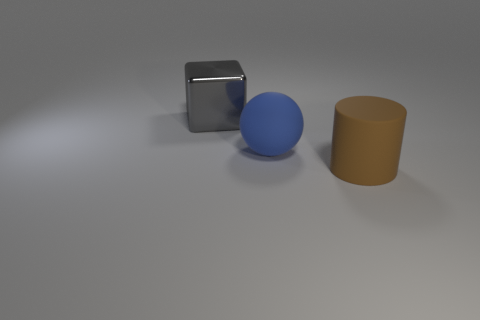What number of big blocks are behind the large object behind the ball?
Offer a terse response. 0. Is there anything else that is the same material as the gray cube?
Offer a terse response. No. Does the large brown object have the same material as the large thing behind the large matte ball?
Your answer should be very brief. No. Are there fewer big rubber cylinders that are on the left side of the big blue rubber thing than metal objects in front of the large gray metallic cube?
Provide a succinct answer. No. What is the big object that is right of the blue object made of?
Offer a very short reply. Rubber. There is a big thing that is both in front of the gray block and behind the large brown cylinder; what is its color?
Your answer should be very brief. Blue. How many other things are there of the same color as the matte sphere?
Offer a terse response. 0. The large thing on the right side of the large rubber sphere is what color?
Provide a succinct answer. Brown. Is there a blue shiny cylinder of the same size as the metal thing?
Offer a terse response. No. There is a gray cube that is the same size as the brown matte object; what is it made of?
Make the answer very short. Metal. 